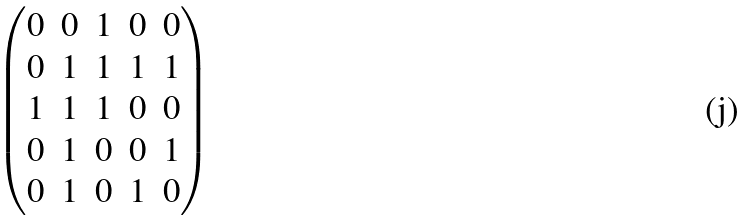Convert formula to latex. <formula><loc_0><loc_0><loc_500><loc_500>\begin{pmatrix} 0 & 0 & 1 & 0 & 0 \\ 0 & 1 & 1 & 1 & 1 \\ 1 & 1 & 1 & 0 & 0 \\ 0 & 1 & 0 & 0 & 1 \\ 0 & 1 & 0 & 1 & 0 \\ \end{pmatrix}</formula> 